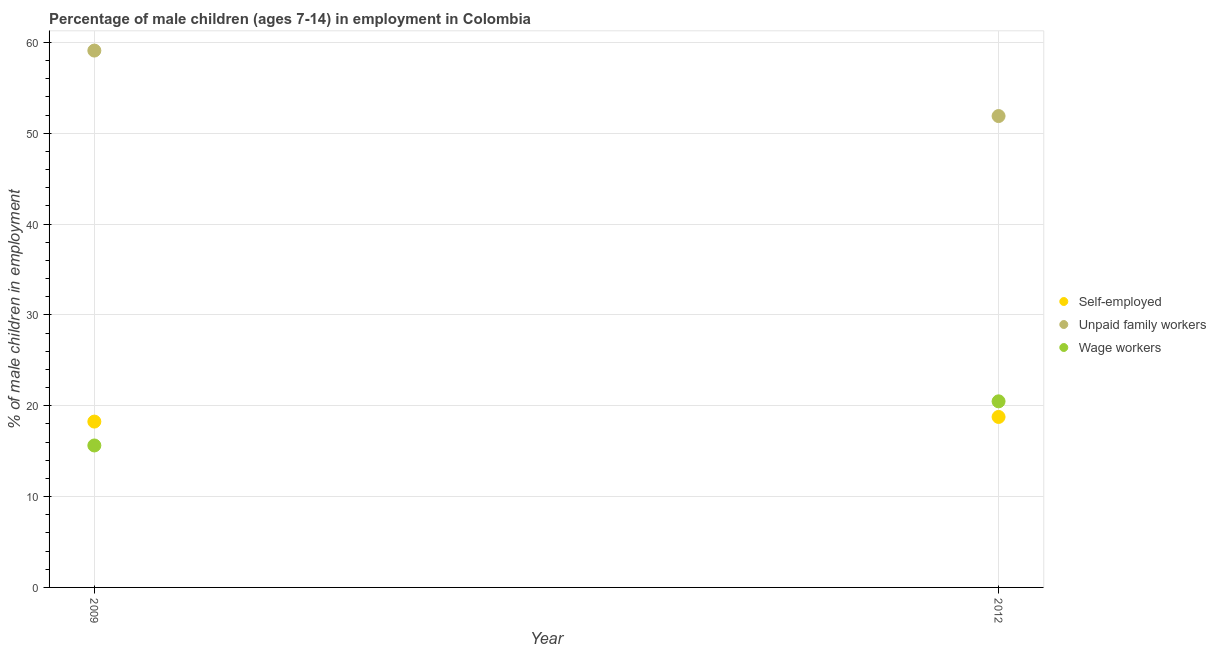How many different coloured dotlines are there?
Provide a short and direct response. 3. What is the percentage of children employed as wage workers in 2009?
Keep it short and to the point. 15.63. Across all years, what is the maximum percentage of children employed as unpaid family workers?
Your answer should be compact. 59.11. Across all years, what is the minimum percentage of children employed as unpaid family workers?
Provide a succinct answer. 51.9. What is the total percentage of self employed children in the graph?
Give a very brief answer. 37.03. What is the difference between the percentage of children employed as wage workers in 2009 and that in 2012?
Your response must be concise. -4.86. What is the difference between the percentage of children employed as unpaid family workers in 2012 and the percentage of self employed children in 2009?
Ensure brevity in your answer.  33.64. What is the average percentage of children employed as unpaid family workers per year?
Keep it short and to the point. 55.5. In the year 2012, what is the difference between the percentage of self employed children and percentage of children employed as unpaid family workers?
Ensure brevity in your answer.  -33.13. In how many years, is the percentage of self employed children greater than 18 %?
Keep it short and to the point. 2. What is the ratio of the percentage of self employed children in 2009 to that in 2012?
Ensure brevity in your answer.  0.97. Is the percentage of self employed children in 2009 less than that in 2012?
Your response must be concise. Yes. In how many years, is the percentage of self employed children greater than the average percentage of self employed children taken over all years?
Offer a terse response. 1. Does the percentage of children employed as wage workers monotonically increase over the years?
Your response must be concise. Yes. Is the percentage of children employed as wage workers strictly less than the percentage of self employed children over the years?
Make the answer very short. No. How many years are there in the graph?
Offer a very short reply. 2. Are the values on the major ticks of Y-axis written in scientific E-notation?
Ensure brevity in your answer.  No. What is the title of the graph?
Your response must be concise. Percentage of male children (ages 7-14) in employment in Colombia. Does "Labor Market" appear as one of the legend labels in the graph?
Provide a succinct answer. No. What is the label or title of the Y-axis?
Provide a short and direct response. % of male children in employment. What is the % of male children in employment in Self-employed in 2009?
Offer a very short reply. 18.26. What is the % of male children in employment of Unpaid family workers in 2009?
Offer a very short reply. 59.11. What is the % of male children in employment of Wage workers in 2009?
Provide a succinct answer. 15.63. What is the % of male children in employment in Self-employed in 2012?
Your response must be concise. 18.77. What is the % of male children in employment of Unpaid family workers in 2012?
Provide a short and direct response. 51.9. What is the % of male children in employment in Wage workers in 2012?
Your response must be concise. 20.49. Across all years, what is the maximum % of male children in employment of Self-employed?
Your answer should be very brief. 18.77. Across all years, what is the maximum % of male children in employment of Unpaid family workers?
Provide a succinct answer. 59.11. Across all years, what is the maximum % of male children in employment in Wage workers?
Provide a succinct answer. 20.49. Across all years, what is the minimum % of male children in employment of Self-employed?
Give a very brief answer. 18.26. Across all years, what is the minimum % of male children in employment of Unpaid family workers?
Offer a very short reply. 51.9. Across all years, what is the minimum % of male children in employment in Wage workers?
Make the answer very short. 15.63. What is the total % of male children in employment of Self-employed in the graph?
Offer a terse response. 37.03. What is the total % of male children in employment of Unpaid family workers in the graph?
Your response must be concise. 111.01. What is the total % of male children in employment in Wage workers in the graph?
Ensure brevity in your answer.  36.12. What is the difference between the % of male children in employment in Self-employed in 2009 and that in 2012?
Give a very brief answer. -0.51. What is the difference between the % of male children in employment in Unpaid family workers in 2009 and that in 2012?
Ensure brevity in your answer.  7.21. What is the difference between the % of male children in employment in Wage workers in 2009 and that in 2012?
Give a very brief answer. -4.86. What is the difference between the % of male children in employment of Self-employed in 2009 and the % of male children in employment of Unpaid family workers in 2012?
Provide a short and direct response. -33.64. What is the difference between the % of male children in employment in Self-employed in 2009 and the % of male children in employment in Wage workers in 2012?
Make the answer very short. -2.23. What is the difference between the % of male children in employment of Unpaid family workers in 2009 and the % of male children in employment of Wage workers in 2012?
Ensure brevity in your answer.  38.62. What is the average % of male children in employment in Self-employed per year?
Offer a very short reply. 18.52. What is the average % of male children in employment in Unpaid family workers per year?
Offer a terse response. 55.51. What is the average % of male children in employment of Wage workers per year?
Make the answer very short. 18.06. In the year 2009, what is the difference between the % of male children in employment in Self-employed and % of male children in employment in Unpaid family workers?
Keep it short and to the point. -40.85. In the year 2009, what is the difference between the % of male children in employment of Self-employed and % of male children in employment of Wage workers?
Your response must be concise. 2.63. In the year 2009, what is the difference between the % of male children in employment of Unpaid family workers and % of male children in employment of Wage workers?
Provide a succinct answer. 43.48. In the year 2012, what is the difference between the % of male children in employment of Self-employed and % of male children in employment of Unpaid family workers?
Your answer should be very brief. -33.13. In the year 2012, what is the difference between the % of male children in employment in Self-employed and % of male children in employment in Wage workers?
Offer a terse response. -1.72. In the year 2012, what is the difference between the % of male children in employment of Unpaid family workers and % of male children in employment of Wage workers?
Offer a terse response. 31.41. What is the ratio of the % of male children in employment in Self-employed in 2009 to that in 2012?
Make the answer very short. 0.97. What is the ratio of the % of male children in employment of Unpaid family workers in 2009 to that in 2012?
Keep it short and to the point. 1.14. What is the ratio of the % of male children in employment in Wage workers in 2009 to that in 2012?
Provide a short and direct response. 0.76. What is the difference between the highest and the second highest % of male children in employment of Self-employed?
Your answer should be compact. 0.51. What is the difference between the highest and the second highest % of male children in employment of Unpaid family workers?
Ensure brevity in your answer.  7.21. What is the difference between the highest and the second highest % of male children in employment in Wage workers?
Keep it short and to the point. 4.86. What is the difference between the highest and the lowest % of male children in employment of Self-employed?
Keep it short and to the point. 0.51. What is the difference between the highest and the lowest % of male children in employment in Unpaid family workers?
Keep it short and to the point. 7.21. What is the difference between the highest and the lowest % of male children in employment in Wage workers?
Make the answer very short. 4.86. 